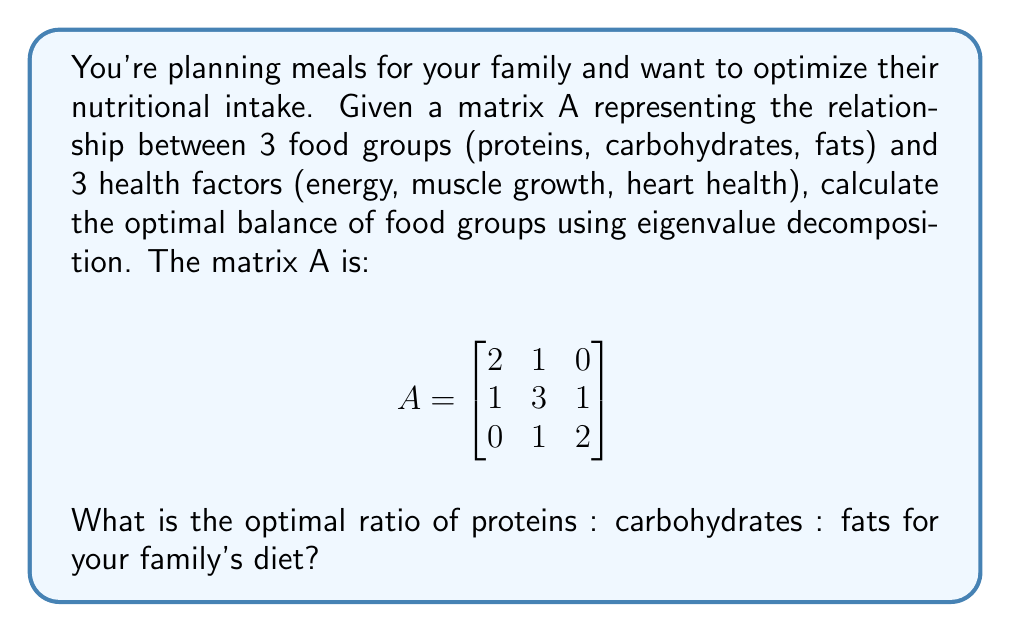Could you help me with this problem? To find the optimal balance, we need to calculate the eigenvector corresponding to the largest eigenvalue of matrix A. This eigenvector will represent the optimal ratio of food groups.

Step 1: Calculate the characteristic polynomial of A:
$det(A - \lambda I) = \begin{vmatrix}
2-\lambda & 1 & 0 \\
1 & 3-\lambda & 1 \\
0 & 1 & 2-\lambda
\end{vmatrix} = -\lambda^3 + 7\lambda^2 - 15\lambda + 9$

Step 2: Find the eigenvalues by solving the characteristic equation:
$-\lambda^3 + 7\lambda^2 - 15\lambda + 9 = 0$

The largest eigenvalue is $\lambda_1 = 4$.

Step 3: Find the eigenvector $v$ corresponding to $\lambda_1 = 4$:
$(A - 4I)v = 0$

$\begin{bmatrix}
-2 & 1 & 0 \\
1 & -1 & 1 \\
0 & 1 & -2
\end{bmatrix} \begin{bmatrix}
v_1 \\
v_2 \\
v_3
\end{bmatrix} = \begin{bmatrix}
0 \\
0 \\
0
\end{bmatrix}$

Solving this system of equations gives us:
$v_1 = 1, v_2 = 2, v_3 = 1$

Step 4: Normalize the eigenvector to get the optimal ratio:
$\sqrt{1^2 + 2^2 + 1^2} = \sqrt{6}$

Normalized eigenvector: $(\frac{1}{\sqrt{6}}, \frac{2}{\sqrt{6}}, \frac{1}{\sqrt{6}})$

This represents the optimal ratio of proteins : carbohydrates : fats.
Answer: $1 : 2 : 1$ 